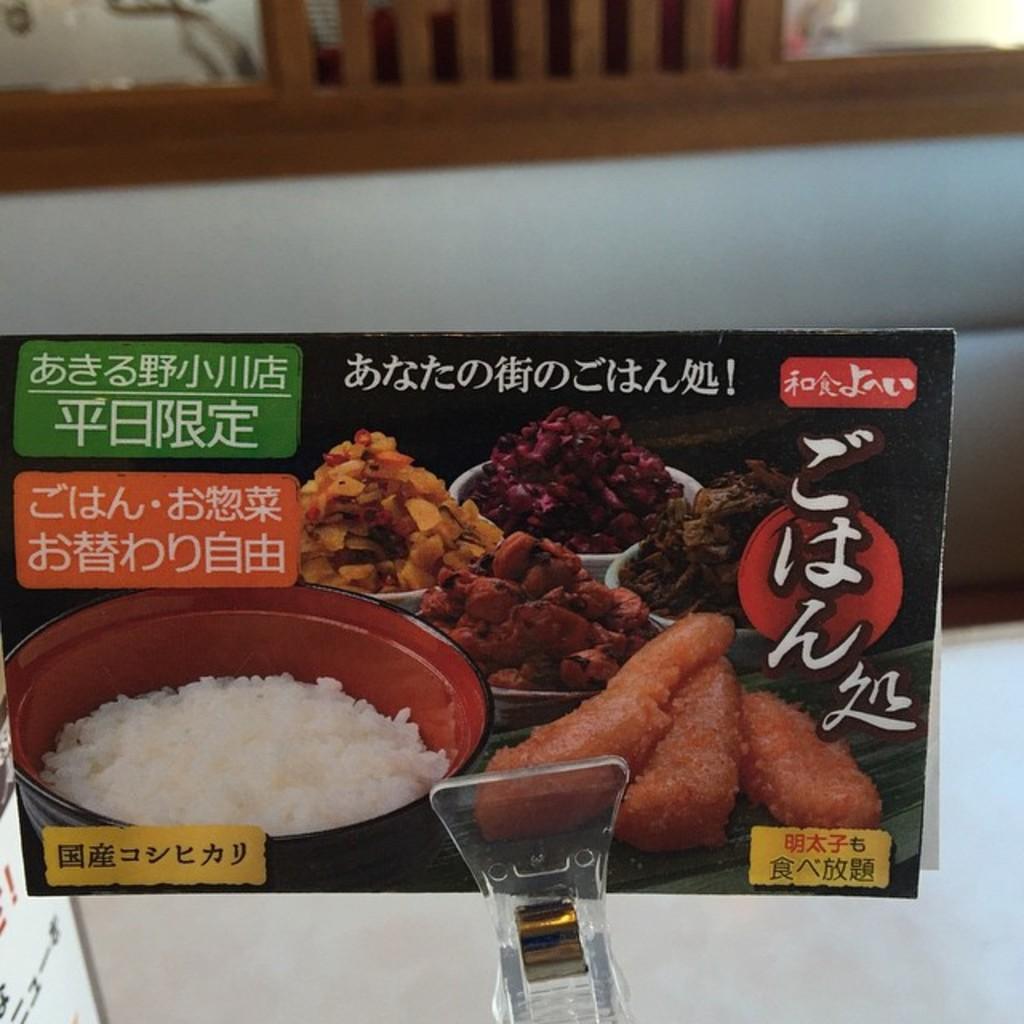Could you give a brief overview of what you see in this image? In this image I can see a paper which is black in color and on it I can see few food items and a black colored bowl with rice in it. I can see it is held by a glass object. In the background I can see a couch which is white and brown in color and a chair which is brown in color. 